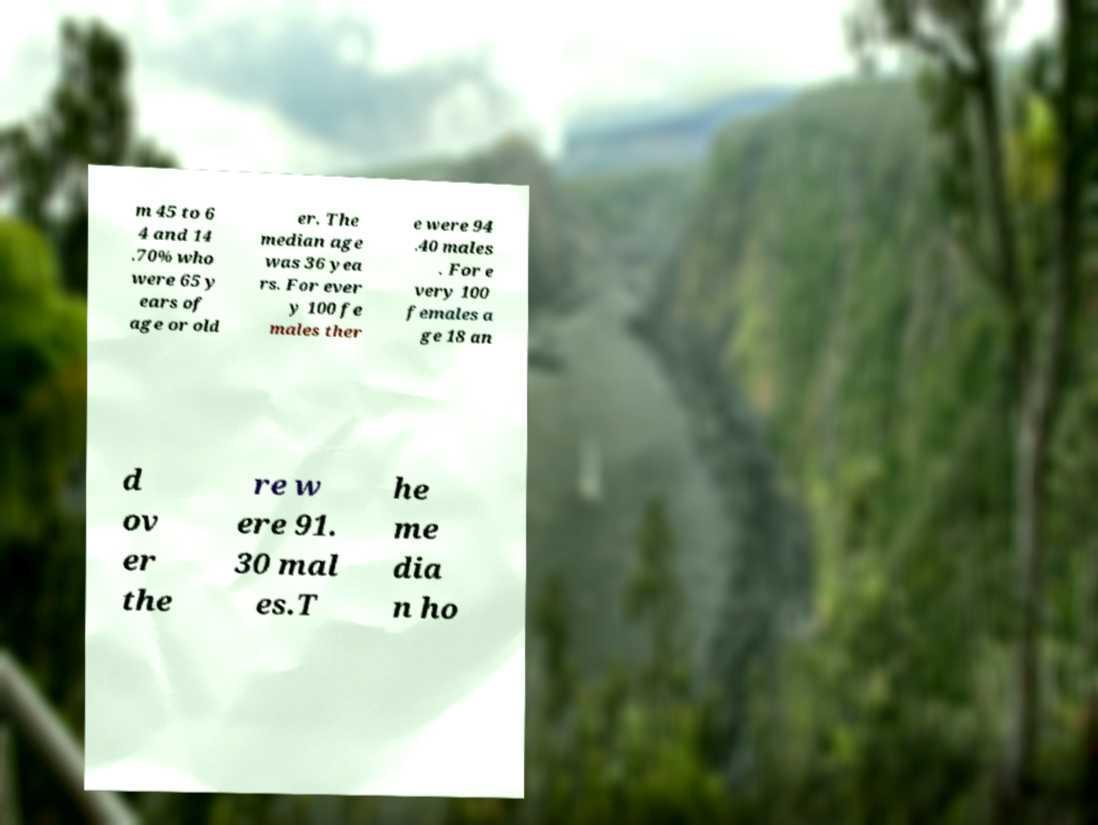Could you assist in decoding the text presented in this image and type it out clearly? m 45 to 6 4 and 14 .70% who were 65 y ears of age or old er. The median age was 36 yea rs. For ever y 100 fe males ther e were 94 .40 males . For e very 100 females a ge 18 an d ov er the re w ere 91. 30 mal es.T he me dia n ho 